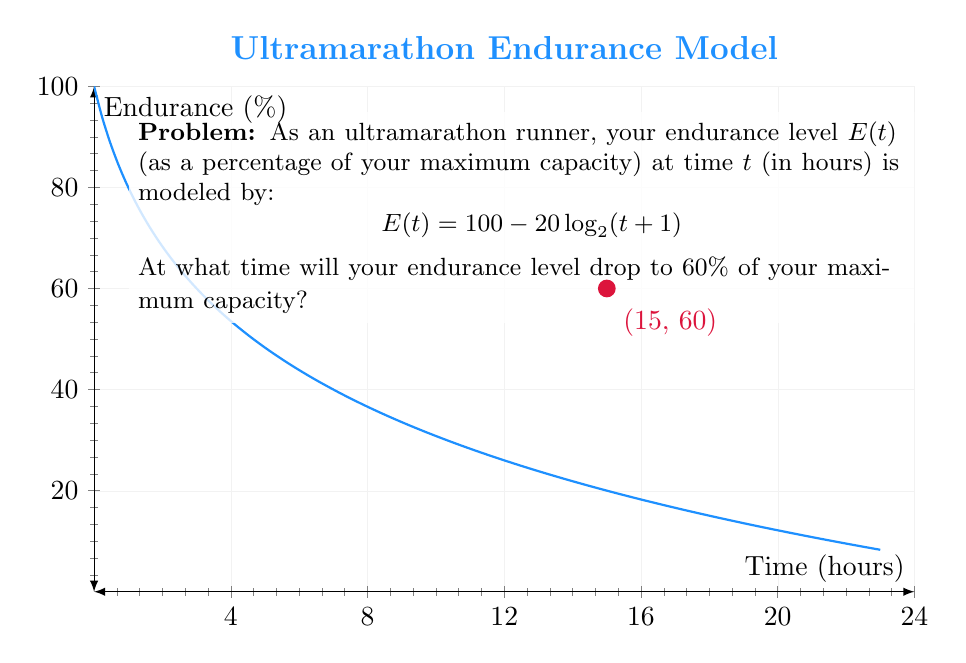Solve this math problem. Let's solve this step-by-step:

1) We want to find $t$ when $E(t) = 60$. So, we set up the equation:

   $$60 = 100 - 20\log_2(t+1)$$

2) Subtract 100 from both sides:

   $$-40 = -20\log_2(t+1)$$

3) Divide both sides by -20:

   $$2 = \log_2(t+1)$$

4) Now, we need to solve for $t$. We can do this by applying $2^x$ to both sides:

   $$2^2 = 2^{\log_2(t+1)}$$

5) Simplify the left side:

   $$4 = t+1$$

6) Subtract 1 from both sides to isolate $t$:

   $$3 = t$$

Therefore, your endurance level will drop to 60% after 3 hours of running.
Answer: 3 hours 